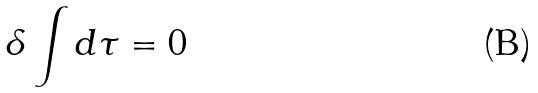Convert formula to latex. <formula><loc_0><loc_0><loc_500><loc_500>\delta \int d \tau = 0</formula> 